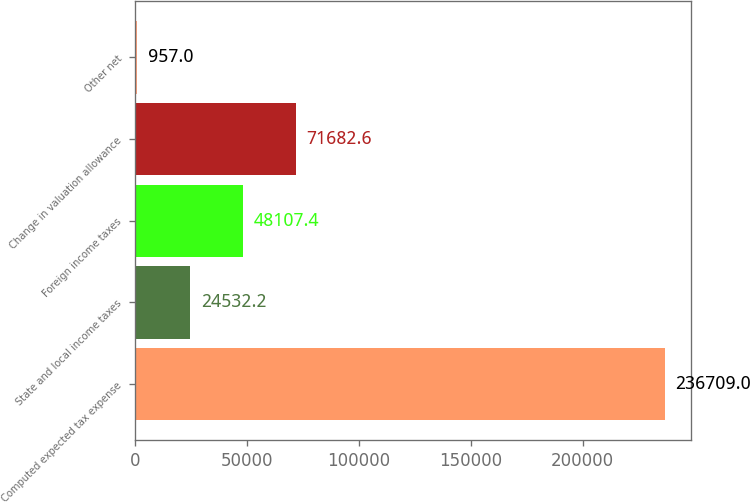Convert chart to OTSL. <chart><loc_0><loc_0><loc_500><loc_500><bar_chart><fcel>Computed expected tax expense<fcel>State and local income taxes<fcel>Foreign income taxes<fcel>Change in valuation allowance<fcel>Other net<nl><fcel>236709<fcel>24532.2<fcel>48107.4<fcel>71682.6<fcel>957<nl></chart> 